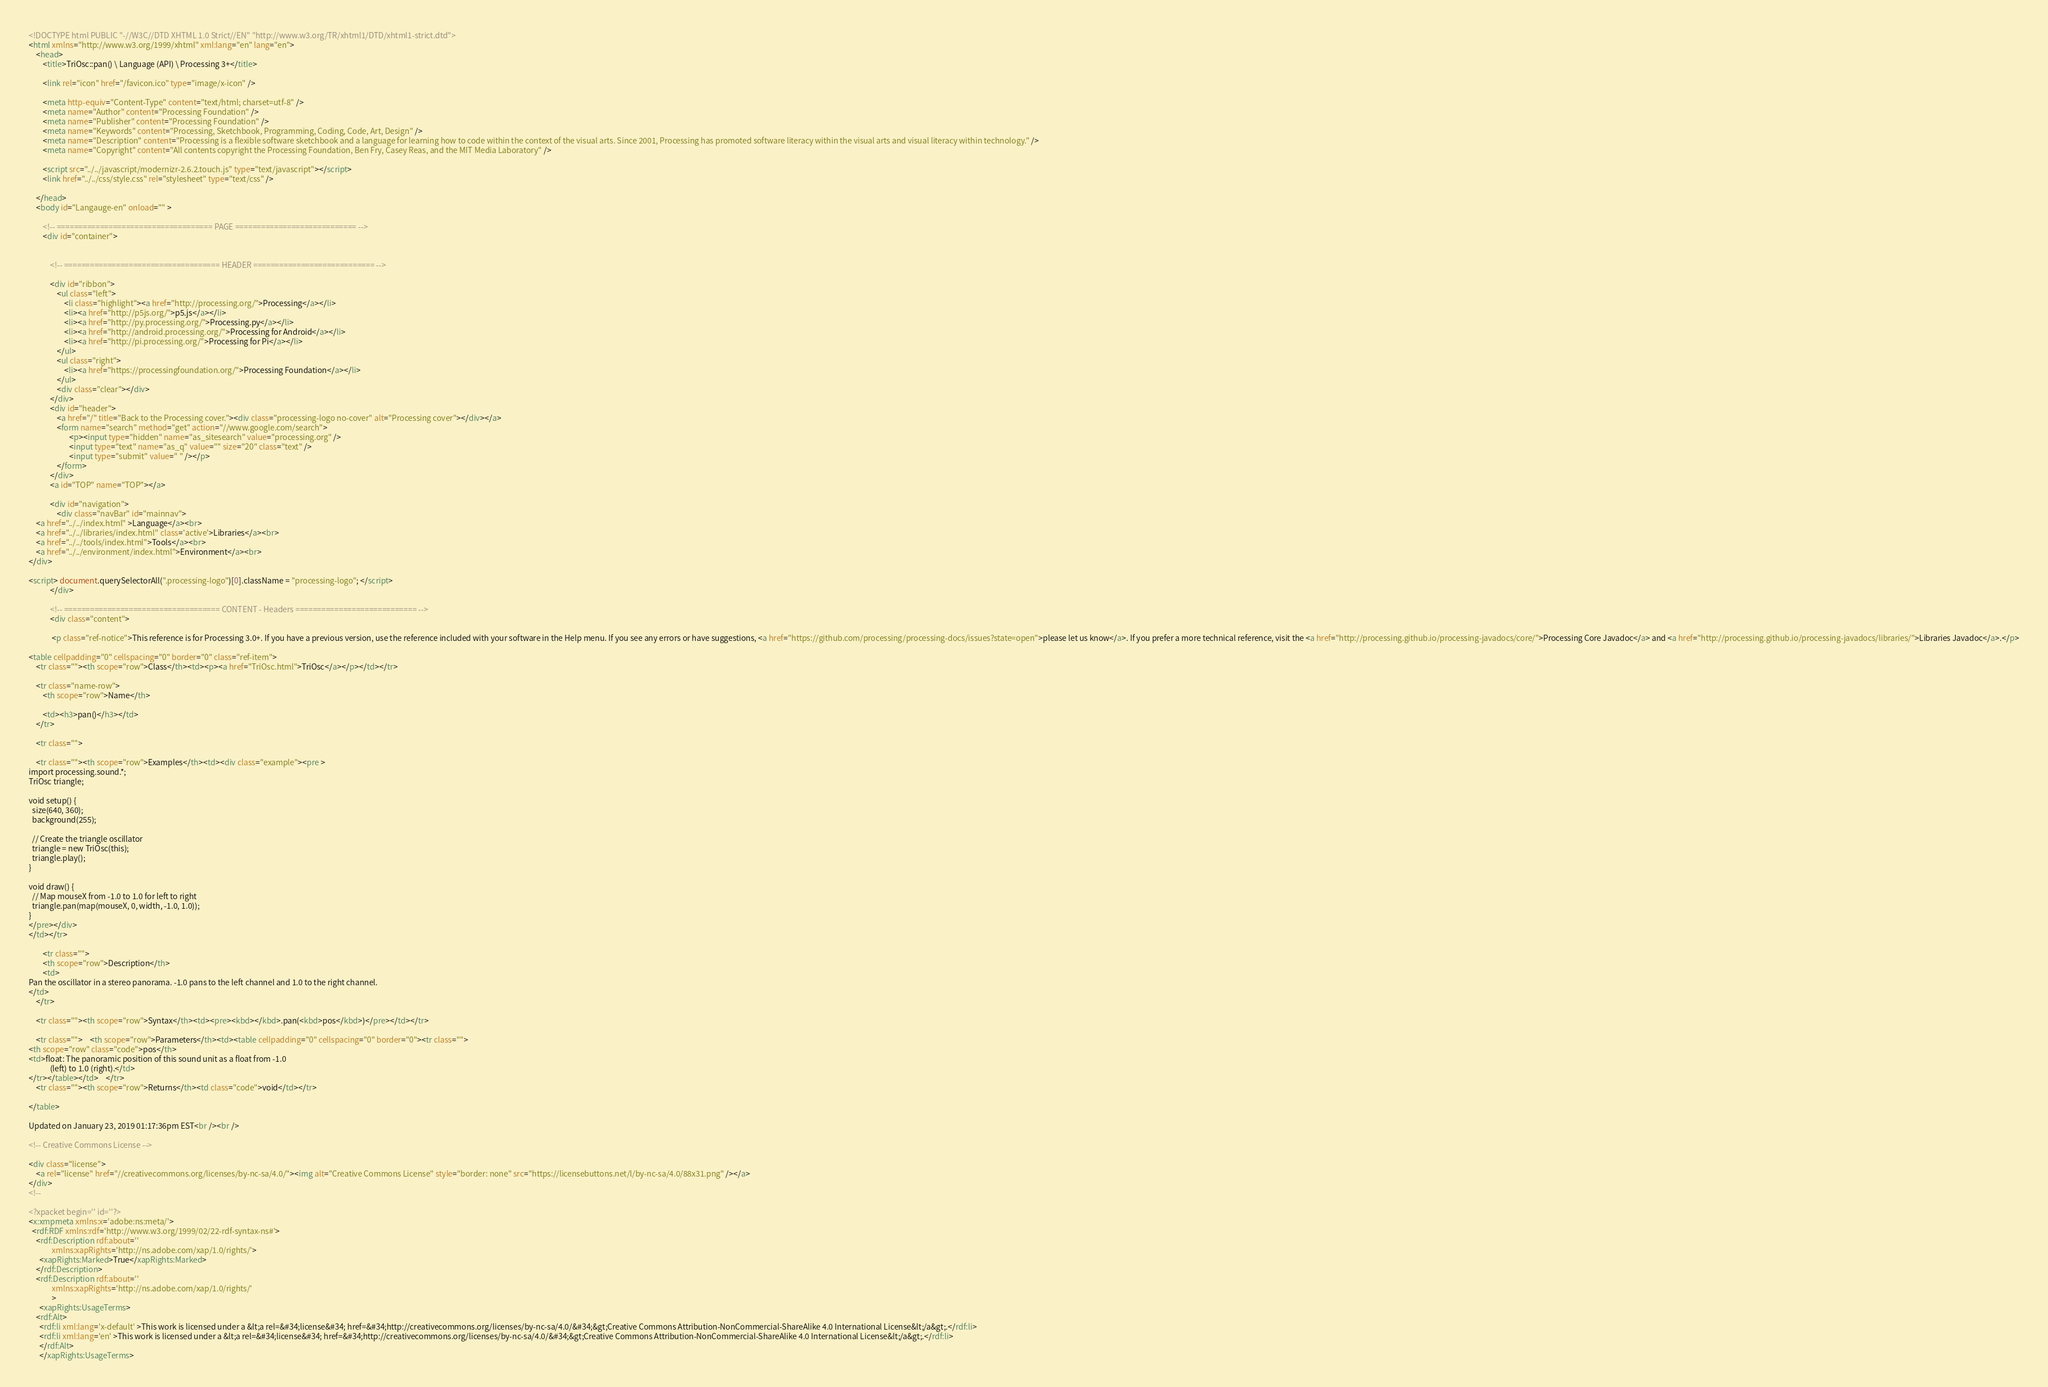<code> <loc_0><loc_0><loc_500><loc_500><_HTML_><!DOCTYPE html PUBLIC "-//W3C//DTD XHTML 1.0 Strict//EN" "http://www.w3.org/TR/xhtml1/DTD/xhtml1-strict.dtd">
<html xmlns="http://www.w3.org/1999/xhtml" xml:lang="en" lang="en">
	<head>
		<title>TriOsc::pan() \ Language (API) \ Processing 3+</title>

		<link rel="icon" href="/favicon.ico" type="image/x-icon" />

		<meta http-equiv="Content-Type" content="text/html; charset=utf-8" />
		<meta name="Author" content="Processing Foundation" />
		<meta name="Publisher" content="Processing Foundation" />
		<meta name="Keywords" content="Processing, Sketchbook, Programming, Coding, Code, Art, Design" />
		<meta name="Description" content="Processing is a flexible software sketchbook and a language for learning how to code within the context of the visual arts. Since 2001, Processing has promoted software literacy within the visual arts and visual literacy within technology." />
		<meta name="Copyright" content="All contents copyright the Processing Foundation, Ben Fry, Casey Reas, and the MIT Media Laboratory" />

		<script src="../../javascript/modernizr-2.6.2.touch.js" type="text/javascript"></script>
		<link href="../../css/style.css" rel="stylesheet" type="text/css" />

	</head>
	<body id="Langauge-en" onload="" >

		<!-- ==================================== PAGE ============================ -->
		<div id="container">


			<!-- ==================================== HEADER ============================ -->

			<div id="ribbon">
				<ul class="left">
					<li class="highlight"><a href="http://processing.org/">Processing</a></li>
					<li><a href="http://p5js.org/">p5.js</a></li>
					<li><a href="http://py.processing.org/">Processing.py</a></li>
					<li><a href="http://android.processing.org/">Processing for Android</a></li>
					<li><a href="http://pi.processing.org/">Processing for Pi</a></li>
				</ul>
				<ul class="right">
					<li><a href="https://processingfoundation.org/">Processing Foundation</a></li>
				</ul>
				<div class="clear"></div>
			</div>
			<div id="header">
				<a href="/" title="Back to the Processing cover."><div class="processing-logo no-cover" alt="Processing cover"></div></a>
				<form name="search" method="get" action="//www.google.com/search">
				       <p><input type="hidden" name="as_sitesearch" value="processing.org" />
				       <input type="text" name="as_q" value="" size="20" class="text" />
				       <input type="submit" value=" " /></p>
				</form>
			</div>
			<a id="TOP" name="TOP"></a>

			<div id="navigation">
				<div class="navBar" id="mainnav">
	<a href="../../index.html" >Language</a><br>
	<a href="../../libraries/index.html" class='active'>Libraries</a><br>
	<a href="../../tools/index.html">Tools</a><br>
	<a href="../../environment/index.html">Environment</a><br>
</div>

<script> document.querySelectorAll(".processing-logo")[0].className = "processing-logo"; </script>
			</div>

			<!-- ==================================== CONTENT - Headers ============================ -->
			<div class="content">

			 <p class="ref-notice">This reference is for Processing 3.0+. If you have a previous version, use the reference included with your software in the Help menu. If you see any errors or have suggestions, <a href="https://github.com/processing/processing-docs/issues?state=open">please let us know</a>. If you prefer a more technical reference, visit the <a href="http://processing.github.io/processing-javadocs/core/">Processing Core Javadoc</a> and <a href="http://processing.github.io/processing-javadocs/libraries/">Libraries Javadoc</a>.</p>

<table cellpadding="0" cellspacing="0" border="0" class="ref-item">
	<tr class=""><th scope="row">Class</th><td><p><a href="TriOsc.html">TriOsc</a></p></td></tr>

	<tr class="name-row">
		<th scope="row">Name</th>

		<td><h3>pan()</h3></td>
	</tr>

	<tr class="">

	<tr class=""><th scope="row">Examples</th><td><div class="example"><pre >
import processing.sound.*;
TriOsc triangle;

void setup() {
  size(640, 360);
  background(255);
    
  // Create the triangle oscillator
  triangle = new TriOsc(this);
  triangle.play();
}      

void draw() {
  // Map mouseX from -1.0 to 1.0 for left to right
  triangle.pan(map(mouseX, 0, width, -1.0, 1.0));
}
</pre></div>
</td></tr>

		<tr class="">
		<th scope="row">Description</th>
		<td>
Pan the oscillator in a stereo panorama. -1.0 pans to the left channel and 1.0 to the right channel.
</td>
	</tr>

	<tr class=""><th scope="row">Syntax</th><td><pre><kbd></kbd>.pan(<kbd>pos</kbd>)</pre></td></tr>

	<tr class="">	<th scope="row">Parameters</th><td><table cellpadding="0" cellspacing="0" border="0"><tr class="">
<th scope="row" class="code">pos</th>
<td>float: The panoramic position of this sound unit as a float from -1.0
            (left) to 1.0 (right).</td>
</tr></table></td>	</tr>
	<tr class=""><th scope="row">Returns</th><td class="code">void</td></tr>

</table>

Updated on January 23, 2019 01:17:36pm EST<br /><br />

<!-- Creative Commons License -->

<div class="license">
	<a rel="license" href="//creativecommons.org/licenses/by-nc-sa/4.0/"><img alt="Creative Commons License" style="border: none" src="https://licensebuttons.net/l/by-nc-sa/4.0/88x31.png" /></a>
</div>
<!--

<?xpacket begin='' id=''?>
<x:xmpmeta xmlns:x='adobe:ns:meta/'>
  <rdf:RDF xmlns:rdf='http://www.w3.org/1999/02/22-rdf-syntax-ns#'>
    <rdf:Description rdf:about=''
		     xmlns:xapRights='http://ns.adobe.com/xap/1.0/rights/'>
      <xapRights:Marked>True</xapRights:Marked>
    </rdf:Description>
    <rdf:Description rdf:about=''
		     xmlns:xapRights='http://ns.adobe.com/xap/1.0/rights/'
		     >
      <xapRights:UsageTerms>
	<rdf:Alt>
	  <rdf:li xml:lang='x-default' >This work is licensed under a &lt;a rel=&#34;license&#34; href=&#34;http://creativecommons.org/licenses/by-nc-sa/4.0/&#34;&gt;Creative Commons Attribution-NonCommercial-ShareAlike 4.0 International License&lt;/a&gt;.</rdf:li>
	  <rdf:li xml:lang='en' >This work is licensed under a &lt;a rel=&#34;license&#34; href=&#34;http://creativecommons.org/licenses/by-nc-sa/4.0/&#34;&gt;Creative Commons Attribution-NonCommercial-ShareAlike 4.0 International License&lt;/a&gt;.</rdf:li>
	  </rdf:Alt>
      </xapRights:UsageTerms></code> 